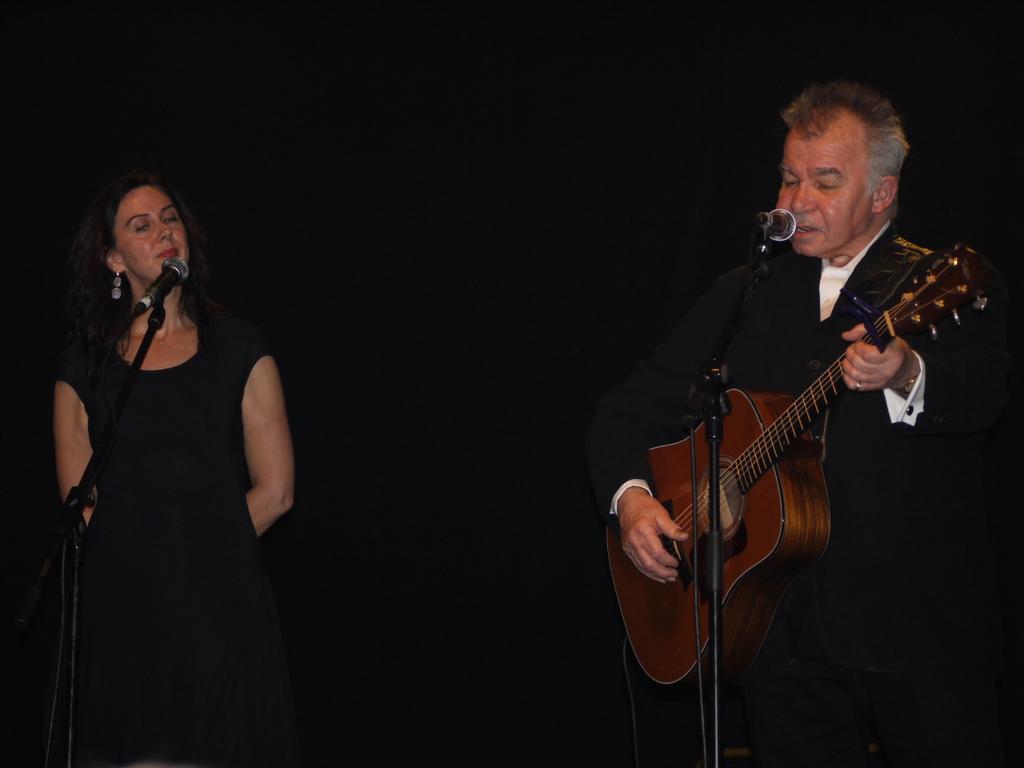In one or two sentences, can you explain what this image depicts? This picture shows a man and woman Standing and we see a man playing guitar and singing with the help of a microphone and we see woman singing with the help of a microphone in front of her 